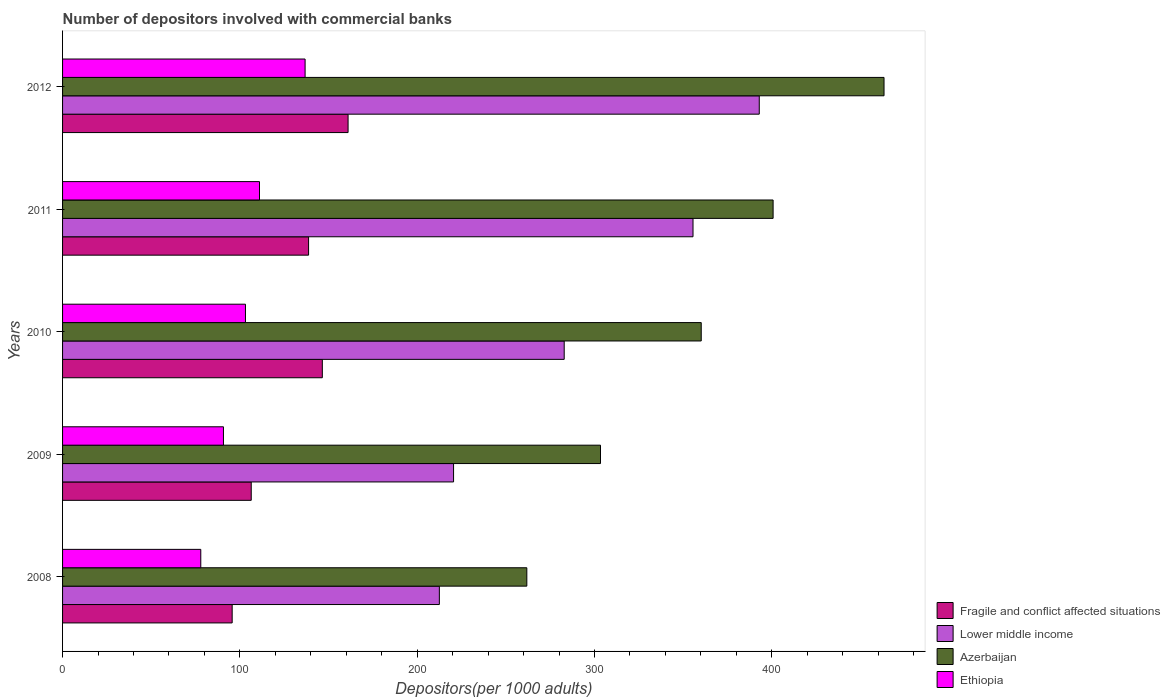Are the number of bars on each tick of the Y-axis equal?
Offer a terse response. Yes. In how many cases, is the number of bars for a given year not equal to the number of legend labels?
Make the answer very short. 0. What is the number of depositors involved with commercial banks in Fragile and conflict affected situations in 2011?
Your response must be concise. 138.74. Across all years, what is the maximum number of depositors involved with commercial banks in Lower middle income?
Provide a succinct answer. 392.92. Across all years, what is the minimum number of depositors involved with commercial banks in Lower middle income?
Provide a succinct answer. 212.5. What is the total number of depositors involved with commercial banks in Lower middle income in the graph?
Keep it short and to the point. 1464.4. What is the difference between the number of depositors involved with commercial banks in Fragile and conflict affected situations in 2009 and that in 2012?
Your answer should be very brief. -54.61. What is the difference between the number of depositors involved with commercial banks in Lower middle income in 2009 and the number of depositors involved with commercial banks in Azerbaijan in 2011?
Make the answer very short. -180.22. What is the average number of depositors involved with commercial banks in Fragile and conflict affected situations per year?
Make the answer very short. 129.66. In the year 2011, what is the difference between the number of depositors involved with commercial banks in Azerbaijan and number of depositors involved with commercial banks in Ethiopia?
Your response must be concise. 289.67. In how many years, is the number of depositors involved with commercial banks in Ethiopia greater than 140 ?
Your answer should be compact. 0. What is the ratio of the number of depositors involved with commercial banks in Fragile and conflict affected situations in 2011 to that in 2012?
Give a very brief answer. 0.86. Is the number of depositors involved with commercial banks in Azerbaijan in 2009 less than that in 2010?
Make the answer very short. Yes. What is the difference between the highest and the second highest number of depositors involved with commercial banks in Fragile and conflict affected situations?
Offer a very short reply. 14.52. What is the difference between the highest and the lowest number of depositors involved with commercial banks in Azerbaijan?
Ensure brevity in your answer.  201.45. Is the sum of the number of depositors involved with commercial banks in Ethiopia in 2008 and 2012 greater than the maximum number of depositors involved with commercial banks in Lower middle income across all years?
Your response must be concise. No. What does the 2nd bar from the top in 2010 represents?
Provide a succinct answer. Azerbaijan. What does the 4th bar from the bottom in 2009 represents?
Your response must be concise. Ethiopia. How many bars are there?
Your answer should be very brief. 20. What is the difference between two consecutive major ticks on the X-axis?
Your answer should be very brief. 100. Are the values on the major ticks of X-axis written in scientific E-notation?
Offer a very short reply. No. Does the graph contain grids?
Provide a short and direct response. No. Where does the legend appear in the graph?
Offer a very short reply. Bottom right. How many legend labels are there?
Your response must be concise. 4. How are the legend labels stacked?
Keep it short and to the point. Vertical. What is the title of the graph?
Offer a terse response. Number of depositors involved with commercial banks. Does "Pakistan" appear as one of the legend labels in the graph?
Your answer should be very brief. No. What is the label or title of the X-axis?
Your answer should be very brief. Depositors(per 1000 adults). What is the label or title of the Y-axis?
Make the answer very short. Years. What is the Depositors(per 1000 adults) of Fragile and conflict affected situations in 2008?
Provide a succinct answer. 95.65. What is the Depositors(per 1000 adults) in Lower middle income in 2008?
Provide a short and direct response. 212.5. What is the Depositors(per 1000 adults) in Azerbaijan in 2008?
Offer a very short reply. 261.83. What is the Depositors(per 1000 adults) of Ethiopia in 2008?
Your response must be concise. 77.95. What is the Depositors(per 1000 adults) in Fragile and conflict affected situations in 2009?
Ensure brevity in your answer.  106.41. What is the Depositors(per 1000 adults) in Lower middle income in 2009?
Ensure brevity in your answer.  220.51. What is the Depositors(per 1000 adults) in Azerbaijan in 2009?
Your answer should be compact. 303.38. What is the Depositors(per 1000 adults) in Ethiopia in 2009?
Provide a succinct answer. 90.74. What is the Depositors(per 1000 adults) of Fragile and conflict affected situations in 2010?
Make the answer very short. 146.5. What is the Depositors(per 1000 adults) in Lower middle income in 2010?
Your answer should be compact. 282.91. What is the Depositors(per 1000 adults) of Azerbaijan in 2010?
Offer a very short reply. 360.2. What is the Depositors(per 1000 adults) in Ethiopia in 2010?
Provide a short and direct response. 103.16. What is the Depositors(per 1000 adults) in Fragile and conflict affected situations in 2011?
Make the answer very short. 138.74. What is the Depositors(per 1000 adults) of Lower middle income in 2011?
Keep it short and to the point. 355.56. What is the Depositors(per 1000 adults) of Azerbaijan in 2011?
Your response must be concise. 400.73. What is the Depositors(per 1000 adults) in Ethiopia in 2011?
Make the answer very short. 111.06. What is the Depositors(per 1000 adults) of Fragile and conflict affected situations in 2012?
Give a very brief answer. 161.02. What is the Depositors(per 1000 adults) of Lower middle income in 2012?
Offer a terse response. 392.92. What is the Depositors(per 1000 adults) in Azerbaijan in 2012?
Offer a terse response. 463.29. What is the Depositors(per 1000 adults) of Ethiopia in 2012?
Your answer should be compact. 136.78. Across all years, what is the maximum Depositors(per 1000 adults) in Fragile and conflict affected situations?
Make the answer very short. 161.02. Across all years, what is the maximum Depositors(per 1000 adults) of Lower middle income?
Provide a succinct answer. 392.92. Across all years, what is the maximum Depositors(per 1000 adults) in Azerbaijan?
Keep it short and to the point. 463.29. Across all years, what is the maximum Depositors(per 1000 adults) of Ethiopia?
Give a very brief answer. 136.78. Across all years, what is the minimum Depositors(per 1000 adults) in Fragile and conflict affected situations?
Your answer should be very brief. 95.65. Across all years, what is the minimum Depositors(per 1000 adults) of Lower middle income?
Provide a succinct answer. 212.5. Across all years, what is the minimum Depositors(per 1000 adults) of Azerbaijan?
Provide a short and direct response. 261.83. Across all years, what is the minimum Depositors(per 1000 adults) of Ethiopia?
Your answer should be compact. 77.95. What is the total Depositors(per 1000 adults) of Fragile and conflict affected situations in the graph?
Give a very brief answer. 648.32. What is the total Depositors(per 1000 adults) in Lower middle income in the graph?
Your answer should be compact. 1464.4. What is the total Depositors(per 1000 adults) of Azerbaijan in the graph?
Keep it short and to the point. 1789.43. What is the total Depositors(per 1000 adults) in Ethiopia in the graph?
Ensure brevity in your answer.  519.7. What is the difference between the Depositors(per 1000 adults) in Fragile and conflict affected situations in 2008 and that in 2009?
Provide a short and direct response. -10.75. What is the difference between the Depositors(per 1000 adults) in Lower middle income in 2008 and that in 2009?
Offer a very short reply. -8.01. What is the difference between the Depositors(per 1000 adults) of Azerbaijan in 2008 and that in 2009?
Keep it short and to the point. -41.55. What is the difference between the Depositors(per 1000 adults) of Ethiopia in 2008 and that in 2009?
Your response must be concise. -12.79. What is the difference between the Depositors(per 1000 adults) in Fragile and conflict affected situations in 2008 and that in 2010?
Offer a very short reply. -50.84. What is the difference between the Depositors(per 1000 adults) of Lower middle income in 2008 and that in 2010?
Give a very brief answer. -70.41. What is the difference between the Depositors(per 1000 adults) of Azerbaijan in 2008 and that in 2010?
Make the answer very short. -98.36. What is the difference between the Depositors(per 1000 adults) in Ethiopia in 2008 and that in 2010?
Your answer should be very brief. -25.21. What is the difference between the Depositors(per 1000 adults) in Fragile and conflict affected situations in 2008 and that in 2011?
Provide a short and direct response. -43.09. What is the difference between the Depositors(per 1000 adults) of Lower middle income in 2008 and that in 2011?
Offer a very short reply. -143.06. What is the difference between the Depositors(per 1000 adults) in Azerbaijan in 2008 and that in 2011?
Your answer should be very brief. -138.9. What is the difference between the Depositors(per 1000 adults) in Ethiopia in 2008 and that in 2011?
Offer a very short reply. -33.11. What is the difference between the Depositors(per 1000 adults) of Fragile and conflict affected situations in 2008 and that in 2012?
Your answer should be compact. -65.37. What is the difference between the Depositors(per 1000 adults) in Lower middle income in 2008 and that in 2012?
Provide a succinct answer. -180.42. What is the difference between the Depositors(per 1000 adults) in Azerbaijan in 2008 and that in 2012?
Ensure brevity in your answer.  -201.45. What is the difference between the Depositors(per 1000 adults) of Ethiopia in 2008 and that in 2012?
Make the answer very short. -58.83. What is the difference between the Depositors(per 1000 adults) of Fragile and conflict affected situations in 2009 and that in 2010?
Provide a short and direct response. -40.09. What is the difference between the Depositors(per 1000 adults) in Lower middle income in 2009 and that in 2010?
Your answer should be compact. -62.4. What is the difference between the Depositors(per 1000 adults) of Azerbaijan in 2009 and that in 2010?
Ensure brevity in your answer.  -56.81. What is the difference between the Depositors(per 1000 adults) of Ethiopia in 2009 and that in 2010?
Provide a succinct answer. -12.42. What is the difference between the Depositors(per 1000 adults) of Fragile and conflict affected situations in 2009 and that in 2011?
Ensure brevity in your answer.  -32.34. What is the difference between the Depositors(per 1000 adults) of Lower middle income in 2009 and that in 2011?
Offer a terse response. -135.05. What is the difference between the Depositors(per 1000 adults) of Azerbaijan in 2009 and that in 2011?
Your response must be concise. -97.35. What is the difference between the Depositors(per 1000 adults) of Ethiopia in 2009 and that in 2011?
Offer a very short reply. -20.33. What is the difference between the Depositors(per 1000 adults) of Fragile and conflict affected situations in 2009 and that in 2012?
Keep it short and to the point. -54.61. What is the difference between the Depositors(per 1000 adults) in Lower middle income in 2009 and that in 2012?
Provide a short and direct response. -172.41. What is the difference between the Depositors(per 1000 adults) in Azerbaijan in 2009 and that in 2012?
Offer a terse response. -159.9. What is the difference between the Depositors(per 1000 adults) in Ethiopia in 2009 and that in 2012?
Your response must be concise. -46.05. What is the difference between the Depositors(per 1000 adults) in Fragile and conflict affected situations in 2010 and that in 2011?
Keep it short and to the point. 7.75. What is the difference between the Depositors(per 1000 adults) in Lower middle income in 2010 and that in 2011?
Give a very brief answer. -72.64. What is the difference between the Depositors(per 1000 adults) in Azerbaijan in 2010 and that in 2011?
Keep it short and to the point. -40.54. What is the difference between the Depositors(per 1000 adults) in Ethiopia in 2010 and that in 2011?
Ensure brevity in your answer.  -7.91. What is the difference between the Depositors(per 1000 adults) of Fragile and conflict affected situations in 2010 and that in 2012?
Provide a short and direct response. -14.52. What is the difference between the Depositors(per 1000 adults) of Lower middle income in 2010 and that in 2012?
Your response must be concise. -110.01. What is the difference between the Depositors(per 1000 adults) in Azerbaijan in 2010 and that in 2012?
Give a very brief answer. -103.09. What is the difference between the Depositors(per 1000 adults) of Ethiopia in 2010 and that in 2012?
Your answer should be compact. -33.63. What is the difference between the Depositors(per 1000 adults) of Fragile and conflict affected situations in 2011 and that in 2012?
Provide a succinct answer. -22.28. What is the difference between the Depositors(per 1000 adults) in Lower middle income in 2011 and that in 2012?
Your answer should be very brief. -37.36. What is the difference between the Depositors(per 1000 adults) of Azerbaijan in 2011 and that in 2012?
Provide a succinct answer. -62.56. What is the difference between the Depositors(per 1000 adults) in Ethiopia in 2011 and that in 2012?
Make the answer very short. -25.72. What is the difference between the Depositors(per 1000 adults) in Fragile and conflict affected situations in 2008 and the Depositors(per 1000 adults) in Lower middle income in 2009?
Make the answer very short. -124.86. What is the difference between the Depositors(per 1000 adults) in Fragile and conflict affected situations in 2008 and the Depositors(per 1000 adults) in Azerbaijan in 2009?
Keep it short and to the point. -207.73. What is the difference between the Depositors(per 1000 adults) of Fragile and conflict affected situations in 2008 and the Depositors(per 1000 adults) of Ethiopia in 2009?
Offer a very short reply. 4.91. What is the difference between the Depositors(per 1000 adults) of Lower middle income in 2008 and the Depositors(per 1000 adults) of Azerbaijan in 2009?
Give a very brief answer. -90.88. What is the difference between the Depositors(per 1000 adults) of Lower middle income in 2008 and the Depositors(per 1000 adults) of Ethiopia in 2009?
Provide a short and direct response. 121.76. What is the difference between the Depositors(per 1000 adults) in Azerbaijan in 2008 and the Depositors(per 1000 adults) in Ethiopia in 2009?
Your answer should be compact. 171.09. What is the difference between the Depositors(per 1000 adults) in Fragile and conflict affected situations in 2008 and the Depositors(per 1000 adults) in Lower middle income in 2010?
Give a very brief answer. -187.26. What is the difference between the Depositors(per 1000 adults) in Fragile and conflict affected situations in 2008 and the Depositors(per 1000 adults) in Azerbaijan in 2010?
Provide a succinct answer. -264.54. What is the difference between the Depositors(per 1000 adults) in Fragile and conflict affected situations in 2008 and the Depositors(per 1000 adults) in Ethiopia in 2010?
Your answer should be compact. -7.51. What is the difference between the Depositors(per 1000 adults) in Lower middle income in 2008 and the Depositors(per 1000 adults) in Azerbaijan in 2010?
Your answer should be very brief. -147.7. What is the difference between the Depositors(per 1000 adults) in Lower middle income in 2008 and the Depositors(per 1000 adults) in Ethiopia in 2010?
Provide a succinct answer. 109.34. What is the difference between the Depositors(per 1000 adults) of Azerbaijan in 2008 and the Depositors(per 1000 adults) of Ethiopia in 2010?
Keep it short and to the point. 158.68. What is the difference between the Depositors(per 1000 adults) of Fragile and conflict affected situations in 2008 and the Depositors(per 1000 adults) of Lower middle income in 2011?
Provide a succinct answer. -259.91. What is the difference between the Depositors(per 1000 adults) of Fragile and conflict affected situations in 2008 and the Depositors(per 1000 adults) of Azerbaijan in 2011?
Provide a short and direct response. -305.08. What is the difference between the Depositors(per 1000 adults) of Fragile and conflict affected situations in 2008 and the Depositors(per 1000 adults) of Ethiopia in 2011?
Offer a very short reply. -15.41. What is the difference between the Depositors(per 1000 adults) of Lower middle income in 2008 and the Depositors(per 1000 adults) of Azerbaijan in 2011?
Offer a terse response. -188.23. What is the difference between the Depositors(per 1000 adults) of Lower middle income in 2008 and the Depositors(per 1000 adults) of Ethiopia in 2011?
Your answer should be compact. 101.44. What is the difference between the Depositors(per 1000 adults) of Azerbaijan in 2008 and the Depositors(per 1000 adults) of Ethiopia in 2011?
Offer a very short reply. 150.77. What is the difference between the Depositors(per 1000 adults) in Fragile and conflict affected situations in 2008 and the Depositors(per 1000 adults) in Lower middle income in 2012?
Offer a terse response. -297.27. What is the difference between the Depositors(per 1000 adults) of Fragile and conflict affected situations in 2008 and the Depositors(per 1000 adults) of Azerbaijan in 2012?
Provide a short and direct response. -367.64. What is the difference between the Depositors(per 1000 adults) in Fragile and conflict affected situations in 2008 and the Depositors(per 1000 adults) in Ethiopia in 2012?
Provide a short and direct response. -41.13. What is the difference between the Depositors(per 1000 adults) in Lower middle income in 2008 and the Depositors(per 1000 adults) in Azerbaijan in 2012?
Your answer should be compact. -250.79. What is the difference between the Depositors(per 1000 adults) of Lower middle income in 2008 and the Depositors(per 1000 adults) of Ethiopia in 2012?
Provide a short and direct response. 75.72. What is the difference between the Depositors(per 1000 adults) in Azerbaijan in 2008 and the Depositors(per 1000 adults) in Ethiopia in 2012?
Ensure brevity in your answer.  125.05. What is the difference between the Depositors(per 1000 adults) of Fragile and conflict affected situations in 2009 and the Depositors(per 1000 adults) of Lower middle income in 2010?
Give a very brief answer. -176.51. What is the difference between the Depositors(per 1000 adults) of Fragile and conflict affected situations in 2009 and the Depositors(per 1000 adults) of Azerbaijan in 2010?
Your response must be concise. -253.79. What is the difference between the Depositors(per 1000 adults) of Fragile and conflict affected situations in 2009 and the Depositors(per 1000 adults) of Ethiopia in 2010?
Provide a short and direct response. 3.25. What is the difference between the Depositors(per 1000 adults) of Lower middle income in 2009 and the Depositors(per 1000 adults) of Azerbaijan in 2010?
Give a very brief answer. -139.69. What is the difference between the Depositors(per 1000 adults) in Lower middle income in 2009 and the Depositors(per 1000 adults) in Ethiopia in 2010?
Provide a succinct answer. 117.35. What is the difference between the Depositors(per 1000 adults) in Azerbaijan in 2009 and the Depositors(per 1000 adults) in Ethiopia in 2010?
Your response must be concise. 200.23. What is the difference between the Depositors(per 1000 adults) of Fragile and conflict affected situations in 2009 and the Depositors(per 1000 adults) of Lower middle income in 2011?
Ensure brevity in your answer.  -249.15. What is the difference between the Depositors(per 1000 adults) of Fragile and conflict affected situations in 2009 and the Depositors(per 1000 adults) of Azerbaijan in 2011?
Ensure brevity in your answer.  -294.32. What is the difference between the Depositors(per 1000 adults) in Fragile and conflict affected situations in 2009 and the Depositors(per 1000 adults) in Ethiopia in 2011?
Provide a short and direct response. -4.66. What is the difference between the Depositors(per 1000 adults) in Lower middle income in 2009 and the Depositors(per 1000 adults) in Azerbaijan in 2011?
Your answer should be compact. -180.22. What is the difference between the Depositors(per 1000 adults) in Lower middle income in 2009 and the Depositors(per 1000 adults) in Ethiopia in 2011?
Offer a terse response. 109.44. What is the difference between the Depositors(per 1000 adults) in Azerbaijan in 2009 and the Depositors(per 1000 adults) in Ethiopia in 2011?
Give a very brief answer. 192.32. What is the difference between the Depositors(per 1000 adults) in Fragile and conflict affected situations in 2009 and the Depositors(per 1000 adults) in Lower middle income in 2012?
Your answer should be compact. -286.52. What is the difference between the Depositors(per 1000 adults) of Fragile and conflict affected situations in 2009 and the Depositors(per 1000 adults) of Azerbaijan in 2012?
Offer a very short reply. -356.88. What is the difference between the Depositors(per 1000 adults) in Fragile and conflict affected situations in 2009 and the Depositors(per 1000 adults) in Ethiopia in 2012?
Keep it short and to the point. -30.38. What is the difference between the Depositors(per 1000 adults) in Lower middle income in 2009 and the Depositors(per 1000 adults) in Azerbaijan in 2012?
Offer a very short reply. -242.78. What is the difference between the Depositors(per 1000 adults) in Lower middle income in 2009 and the Depositors(per 1000 adults) in Ethiopia in 2012?
Your response must be concise. 83.73. What is the difference between the Depositors(per 1000 adults) of Azerbaijan in 2009 and the Depositors(per 1000 adults) of Ethiopia in 2012?
Your answer should be compact. 166.6. What is the difference between the Depositors(per 1000 adults) of Fragile and conflict affected situations in 2010 and the Depositors(per 1000 adults) of Lower middle income in 2011?
Make the answer very short. -209.06. What is the difference between the Depositors(per 1000 adults) of Fragile and conflict affected situations in 2010 and the Depositors(per 1000 adults) of Azerbaijan in 2011?
Keep it short and to the point. -254.24. What is the difference between the Depositors(per 1000 adults) of Fragile and conflict affected situations in 2010 and the Depositors(per 1000 adults) of Ethiopia in 2011?
Make the answer very short. 35.43. What is the difference between the Depositors(per 1000 adults) in Lower middle income in 2010 and the Depositors(per 1000 adults) in Azerbaijan in 2011?
Provide a succinct answer. -117.82. What is the difference between the Depositors(per 1000 adults) in Lower middle income in 2010 and the Depositors(per 1000 adults) in Ethiopia in 2011?
Keep it short and to the point. 171.85. What is the difference between the Depositors(per 1000 adults) in Azerbaijan in 2010 and the Depositors(per 1000 adults) in Ethiopia in 2011?
Give a very brief answer. 249.13. What is the difference between the Depositors(per 1000 adults) in Fragile and conflict affected situations in 2010 and the Depositors(per 1000 adults) in Lower middle income in 2012?
Offer a very short reply. -246.43. What is the difference between the Depositors(per 1000 adults) in Fragile and conflict affected situations in 2010 and the Depositors(per 1000 adults) in Azerbaijan in 2012?
Your answer should be very brief. -316.79. What is the difference between the Depositors(per 1000 adults) of Fragile and conflict affected situations in 2010 and the Depositors(per 1000 adults) of Ethiopia in 2012?
Your answer should be very brief. 9.71. What is the difference between the Depositors(per 1000 adults) of Lower middle income in 2010 and the Depositors(per 1000 adults) of Azerbaijan in 2012?
Keep it short and to the point. -180.38. What is the difference between the Depositors(per 1000 adults) in Lower middle income in 2010 and the Depositors(per 1000 adults) in Ethiopia in 2012?
Ensure brevity in your answer.  146.13. What is the difference between the Depositors(per 1000 adults) in Azerbaijan in 2010 and the Depositors(per 1000 adults) in Ethiopia in 2012?
Offer a terse response. 223.41. What is the difference between the Depositors(per 1000 adults) in Fragile and conflict affected situations in 2011 and the Depositors(per 1000 adults) in Lower middle income in 2012?
Your answer should be very brief. -254.18. What is the difference between the Depositors(per 1000 adults) in Fragile and conflict affected situations in 2011 and the Depositors(per 1000 adults) in Azerbaijan in 2012?
Your answer should be compact. -324.54. What is the difference between the Depositors(per 1000 adults) in Fragile and conflict affected situations in 2011 and the Depositors(per 1000 adults) in Ethiopia in 2012?
Your response must be concise. 1.96. What is the difference between the Depositors(per 1000 adults) of Lower middle income in 2011 and the Depositors(per 1000 adults) of Azerbaijan in 2012?
Offer a terse response. -107.73. What is the difference between the Depositors(per 1000 adults) in Lower middle income in 2011 and the Depositors(per 1000 adults) in Ethiopia in 2012?
Give a very brief answer. 218.77. What is the difference between the Depositors(per 1000 adults) of Azerbaijan in 2011 and the Depositors(per 1000 adults) of Ethiopia in 2012?
Provide a succinct answer. 263.95. What is the average Depositors(per 1000 adults) of Fragile and conflict affected situations per year?
Provide a short and direct response. 129.66. What is the average Depositors(per 1000 adults) of Lower middle income per year?
Your answer should be compact. 292.88. What is the average Depositors(per 1000 adults) of Azerbaijan per year?
Provide a short and direct response. 357.89. What is the average Depositors(per 1000 adults) in Ethiopia per year?
Offer a very short reply. 103.94. In the year 2008, what is the difference between the Depositors(per 1000 adults) of Fragile and conflict affected situations and Depositors(per 1000 adults) of Lower middle income?
Give a very brief answer. -116.85. In the year 2008, what is the difference between the Depositors(per 1000 adults) of Fragile and conflict affected situations and Depositors(per 1000 adults) of Azerbaijan?
Provide a succinct answer. -166.18. In the year 2008, what is the difference between the Depositors(per 1000 adults) in Fragile and conflict affected situations and Depositors(per 1000 adults) in Ethiopia?
Your response must be concise. 17.7. In the year 2008, what is the difference between the Depositors(per 1000 adults) in Lower middle income and Depositors(per 1000 adults) in Azerbaijan?
Keep it short and to the point. -49.33. In the year 2008, what is the difference between the Depositors(per 1000 adults) of Lower middle income and Depositors(per 1000 adults) of Ethiopia?
Ensure brevity in your answer.  134.55. In the year 2008, what is the difference between the Depositors(per 1000 adults) of Azerbaijan and Depositors(per 1000 adults) of Ethiopia?
Offer a terse response. 183.88. In the year 2009, what is the difference between the Depositors(per 1000 adults) in Fragile and conflict affected situations and Depositors(per 1000 adults) in Lower middle income?
Make the answer very short. -114.1. In the year 2009, what is the difference between the Depositors(per 1000 adults) in Fragile and conflict affected situations and Depositors(per 1000 adults) in Azerbaijan?
Provide a short and direct response. -196.98. In the year 2009, what is the difference between the Depositors(per 1000 adults) in Fragile and conflict affected situations and Depositors(per 1000 adults) in Ethiopia?
Keep it short and to the point. 15.67. In the year 2009, what is the difference between the Depositors(per 1000 adults) of Lower middle income and Depositors(per 1000 adults) of Azerbaijan?
Make the answer very short. -82.87. In the year 2009, what is the difference between the Depositors(per 1000 adults) in Lower middle income and Depositors(per 1000 adults) in Ethiopia?
Provide a succinct answer. 129.77. In the year 2009, what is the difference between the Depositors(per 1000 adults) in Azerbaijan and Depositors(per 1000 adults) in Ethiopia?
Your response must be concise. 212.64. In the year 2010, what is the difference between the Depositors(per 1000 adults) of Fragile and conflict affected situations and Depositors(per 1000 adults) of Lower middle income?
Offer a very short reply. -136.42. In the year 2010, what is the difference between the Depositors(per 1000 adults) of Fragile and conflict affected situations and Depositors(per 1000 adults) of Azerbaijan?
Keep it short and to the point. -213.7. In the year 2010, what is the difference between the Depositors(per 1000 adults) in Fragile and conflict affected situations and Depositors(per 1000 adults) in Ethiopia?
Give a very brief answer. 43.34. In the year 2010, what is the difference between the Depositors(per 1000 adults) of Lower middle income and Depositors(per 1000 adults) of Azerbaijan?
Ensure brevity in your answer.  -77.28. In the year 2010, what is the difference between the Depositors(per 1000 adults) of Lower middle income and Depositors(per 1000 adults) of Ethiopia?
Your answer should be very brief. 179.75. In the year 2010, what is the difference between the Depositors(per 1000 adults) in Azerbaijan and Depositors(per 1000 adults) in Ethiopia?
Ensure brevity in your answer.  257.04. In the year 2011, what is the difference between the Depositors(per 1000 adults) of Fragile and conflict affected situations and Depositors(per 1000 adults) of Lower middle income?
Offer a very short reply. -216.81. In the year 2011, what is the difference between the Depositors(per 1000 adults) of Fragile and conflict affected situations and Depositors(per 1000 adults) of Azerbaijan?
Provide a short and direct response. -261.99. In the year 2011, what is the difference between the Depositors(per 1000 adults) of Fragile and conflict affected situations and Depositors(per 1000 adults) of Ethiopia?
Make the answer very short. 27.68. In the year 2011, what is the difference between the Depositors(per 1000 adults) in Lower middle income and Depositors(per 1000 adults) in Azerbaijan?
Your answer should be compact. -45.17. In the year 2011, what is the difference between the Depositors(per 1000 adults) in Lower middle income and Depositors(per 1000 adults) in Ethiopia?
Provide a succinct answer. 244.49. In the year 2011, what is the difference between the Depositors(per 1000 adults) in Azerbaijan and Depositors(per 1000 adults) in Ethiopia?
Your answer should be compact. 289.67. In the year 2012, what is the difference between the Depositors(per 1000 adults) in Fragile and conflict affected situations and Depositors(per 1000 adults) in Lower middle income?
Give a very brief answer. -231.9. In the year 2012, what is the difference between the Depositors(per 1000 adults) of Fragile and conflict affected situations and Depositors(per 1000 adults) of Azerbaijan?
Your answer should be very brief. -302.27. In the year 2012, what is the difference between the Depositors(per 1000 adults) in Fragile and conflict affected situations and Depositors(per 1000 adults) in Ethiopia?
Make the answer very short. 24.24. In the year 2012, what is the difference between the Depositors(per 1000 adults) in Lower middle income and Depositors(per 1000 adults) in Azerbaijan?
Offer a terse response. -70.37. In the year 2012, what is the difference between the Depositors(per 1000 adults) of Lower middle income and Depositors(per 1000 adults) of Ethiopia?
Your response must be concise. 256.14. In the year 2012, what is the difference between the Depositors(per 1000 adults) of Azerbaijan and Depositors(per 1000 adults) of Ethiopia?
Keep it short and to the point. 326.5. What is the ratio of the Depositors(per 1000 adults) of Fragile and conflict affected situations in 2008 to that in 2009?
Provide a succinct answer. 0.9. What is the ratio of the Depositors(per 1000 adults) in Lower middle income in 2008 to that in 2009?
Give a very brief answer. 0.96. What is the ratio of the Depositors(per 1000 adults) in Azerbaijan in 2008 to that in 2009?
Your response must be concise. 0.86. What is the ratio of the Depositors(per 1000 adults) of Ethiopia in 2008 to that in 2009?
Make the answer very short. 0.86. What is the ratio of the Depositors(per 1000 adults) of Fragile and conflict affected situations in 2008 to that in 2010?
Ensure brevity in your answer.  0.65. What is the ratio of the Depositors(per 1000 adults) of Lower middle income in 2008 to that in 2010?
Your answer should be compact. 0.75. What is the ratio of the Depositors(per 1000 adults) in Azerbaijan in 2008 to that in 2010?
Your response must be concise. 0.73. What is the ratio of the Depositors(per 1000 adults) of Ethiopia in 2008 to that in 2010?
Offer a terse response. 0.76. What is the ratio of the Depositors(per 1000 adults) of Fragile and conflict affected situations in 2008 to that in 2011?
Provide a short and direct response. 0.69. What is the ratio of the Depositors(per 1000 adults) of Lower middle income in 2008 to that in 2011?
Offer a very short reply. 0.6. What is the ratio of the Depositors(per 1000 adults) in Azerbaijan in 2008 to that in 2011?
Give a very brief answer. 0.65. What is the ratio of the Depositors(per 1000 adults) of Ethiopia in 2008 to that in 2011?
Offer a very short reply. 0.7. What is the ratio of the Depositors(per 1000 adults) of Fragile and conflict affected situations in 2008 to that in 2012?
Offer a terse response. 0.59. What is the ratio of the Depositors(per 1000 adults) of Lower middle income in 2008 to that in 2012?
Keep it short and to the point. 0.54. What is the ratio of the Depositors(per 1000 adults) of Azerbaijan in 2008 to that in 2012?
Provide a short and direct response. 0.57. What is the ratio of the Depositors(per 1000 adults) of Ethiopia in 2008 to that in 2012?
Provide a succinct answer. 0.57. What is the ratio of the Depositors(per 1000 adults) of Fragile and conflict affected situations in 2009 to that in 2010?
Your answer should be very brief. 0.73. What is the ratio of the Depositors(per 1000 adults) of Lower middle income in 2009 to that in 2010?
Provide a short and direct response. 0.78. What is the ratio of the Depositors(per 1000 adults) of Azerbaijan in 2009 to that in 2010?
Provide a short and direct response. 0.84. What is the ratio of the Depositors(per 1000 adults) of Ethiopia in 2009 to that in 2010?
Make the answer very short. 0.88. What is the ratio of the Depositors(per 1000 adults) in Fragile and conflict affected situations in 2009 to that in 2011?
Your answer should be compact. 0.77. What is the ratio of the Depositors(per 1000 adults) in Lower middle income in 2009 to that in 2011?
Your response must be concise. 0.62. What is the ratio of the Depositors(per 1000 adults) of Azerbaijan in 2009 to that in 2011?
Your answer should be compact. 0.76. What is the ratio of the Depositors(per 1000 adults) of Ethiopia in 2009 to that in 2011?
Provide a succinct answer. 0.82. What is the ratio of the Depositors(per 1000 adults) in Fragile and conflict affected situations in 2009 to that in 2012?
Offer a very short reply. 0.66. What is the ratio of the Depositors(per 1000 adults) in Lower middle income in 2009 to that in 2012?
Offer a terse response. 0.56. What is the ratio of the Depositors(per 1000 adults) in Azerbaijan in 2009 to that in 2012?
Make the answer very short. 0.65. What is the ratio of the Depositors(per 1000 adults) of Ethiopia in 2009 to that in 2012?
Offer a very short reply. 0.66. What is the ratio of the Depositors(per 1000 adults) in Fragile and conflict affected situations in 2010 to that in 2011?
Offer a terse response. 1.06. What is the ratio of the Depositors(per 1000 adults) in Lower middle income in 2010 to that in 2011?
Your answer should be compact. 0.8. What is the ratio of the Depositors(per 1000 adults) of Azerbaijan in 2010 to that in 2011?
Provide a short and direct response. 0.9. What is the ratio of the Depositors(per 1000 adults) of Ethiopia in 2010 to that in 2011?
Provide a short and direct response. 0.93. What is the ratio of the Depositors(per 1000 adults) of Fragile and conflict affected situations in 2010 to that in 2012?
Give a very brief answer. 0.91. What is the ratio of the Depositors(per 1000 adults) of Lower middle income in 2010 to that in 2012?
Your answer should be very brief. 0.72. What is the ratio of the Depositors(per 1000 adults) of Azerbaijan in 2010 to that in 2012?
Give a very brief answer. 0.78. What is the ratio of the Depositors(per 1000 adults) in Ethiopia in 2010 to that in 2012?
Make the answer very short. 0.75. What is the ratio of the Depositors(per 1000 adults) in Fragile and conflict affected situations in 2011 to that in 2012?
Your response must be concise. 0.86. What is the ratio of the Depositors(per 1000 adults) of Lower middle income in 2011 to that in 2012?
Keep it short and to the point. 0.9. What is the ratio of the Depositors(per 1000 adults) of Azerbaijan in 2011 to that in 2012?
Your answer should be compact. 0.86. What is the ratio of the Depositors(per 1000 adults) in Ethiopia in 2011 to that in 2012?
Provide a short and direct response. 0.81. What is the difference between the highest and the second highest Depositors(per 1000 adults) in Fragile and conflict affected situations?
Offer a very short reply. 14.52. What is the difference between the highest and the second highest Depositors(per 1000 adults) of Lower middle income?
Offer a terse response. 37.36. What is the difference between the highest and the second highest Depositors(per 1000 adults) in Azerbaijan?
Offer a terse response. 62.56. What is the difference between the highest and the second highest Depositors(per 1000 adults) of Ethiopia?
Make the answer very short. 25.72. What is the difference between the highest and the lowest Depositors(per 1000 adults) of Fragile and conflict affected situations?
Make the answer very short. 65.37. What is the difference between the highest and the lowest Depositors(per 1000 adults) in Lower middle income?
Your answer should be very brief. 180.42. What is the difference between the highest and the lowest Depositors(per 1000 adults) of Azerbaijan?
Offer a terse response. 201.45. What is the difference between the highest and the lowest Depositors(per 1000 adults) of Ethiopia?
Ensure brevity in your answer.  58.83. 